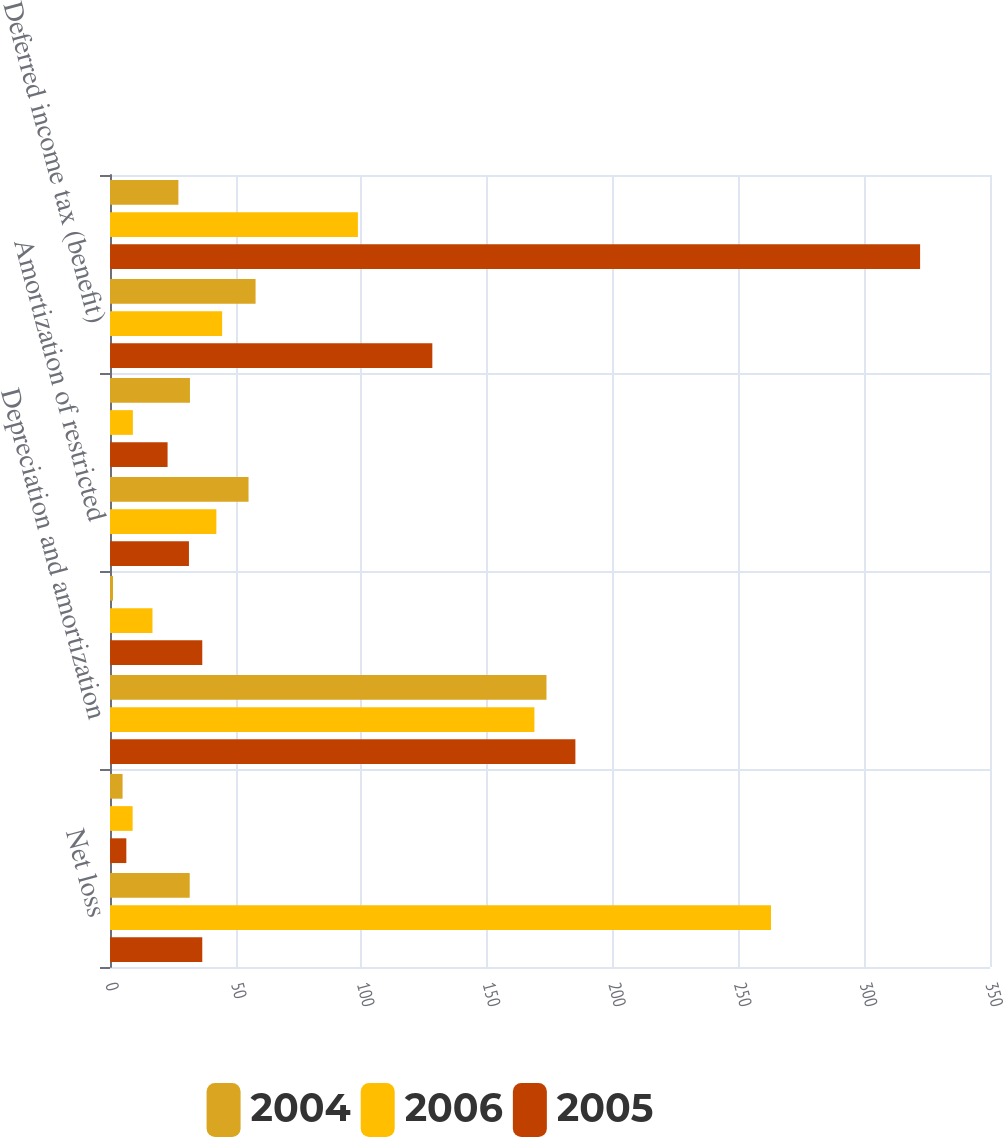Convert chart. <chart><loc_0><loc_0><loc_500><loc_500><stacked_bar_chart><ecel><fcel>Net loss<fcel>Income from discontinued<fcel>Depreciation and amortization<fcel>Provision for bad debt<fcel>Amortization of restricted<fcel>Amortization of bond discounts<fcel>Deferred income tax (benefit)<fcel>Long-lived asset impairment<nl><fcel>2004<fcel>31.7<fcel>5<fcel>173.6<fcel>1.2<fcel>55.1<fcel>31.8<fcel>57.9<fcel>27.2<nl><fcel>2006<fcel>262.9<fcel>9<fcel>168.8<fcel>16.9<fcel>42.3<fcel>9.1<fcel>44.6<fcel>98.6<nl><fcel>2005<fcel>36.7<fcel>6.5<fcel>185.1<fcel>36.7<fcel>31.4<fcel>22.9<fcel>128.2<fcel>322.2<nl></chart> 